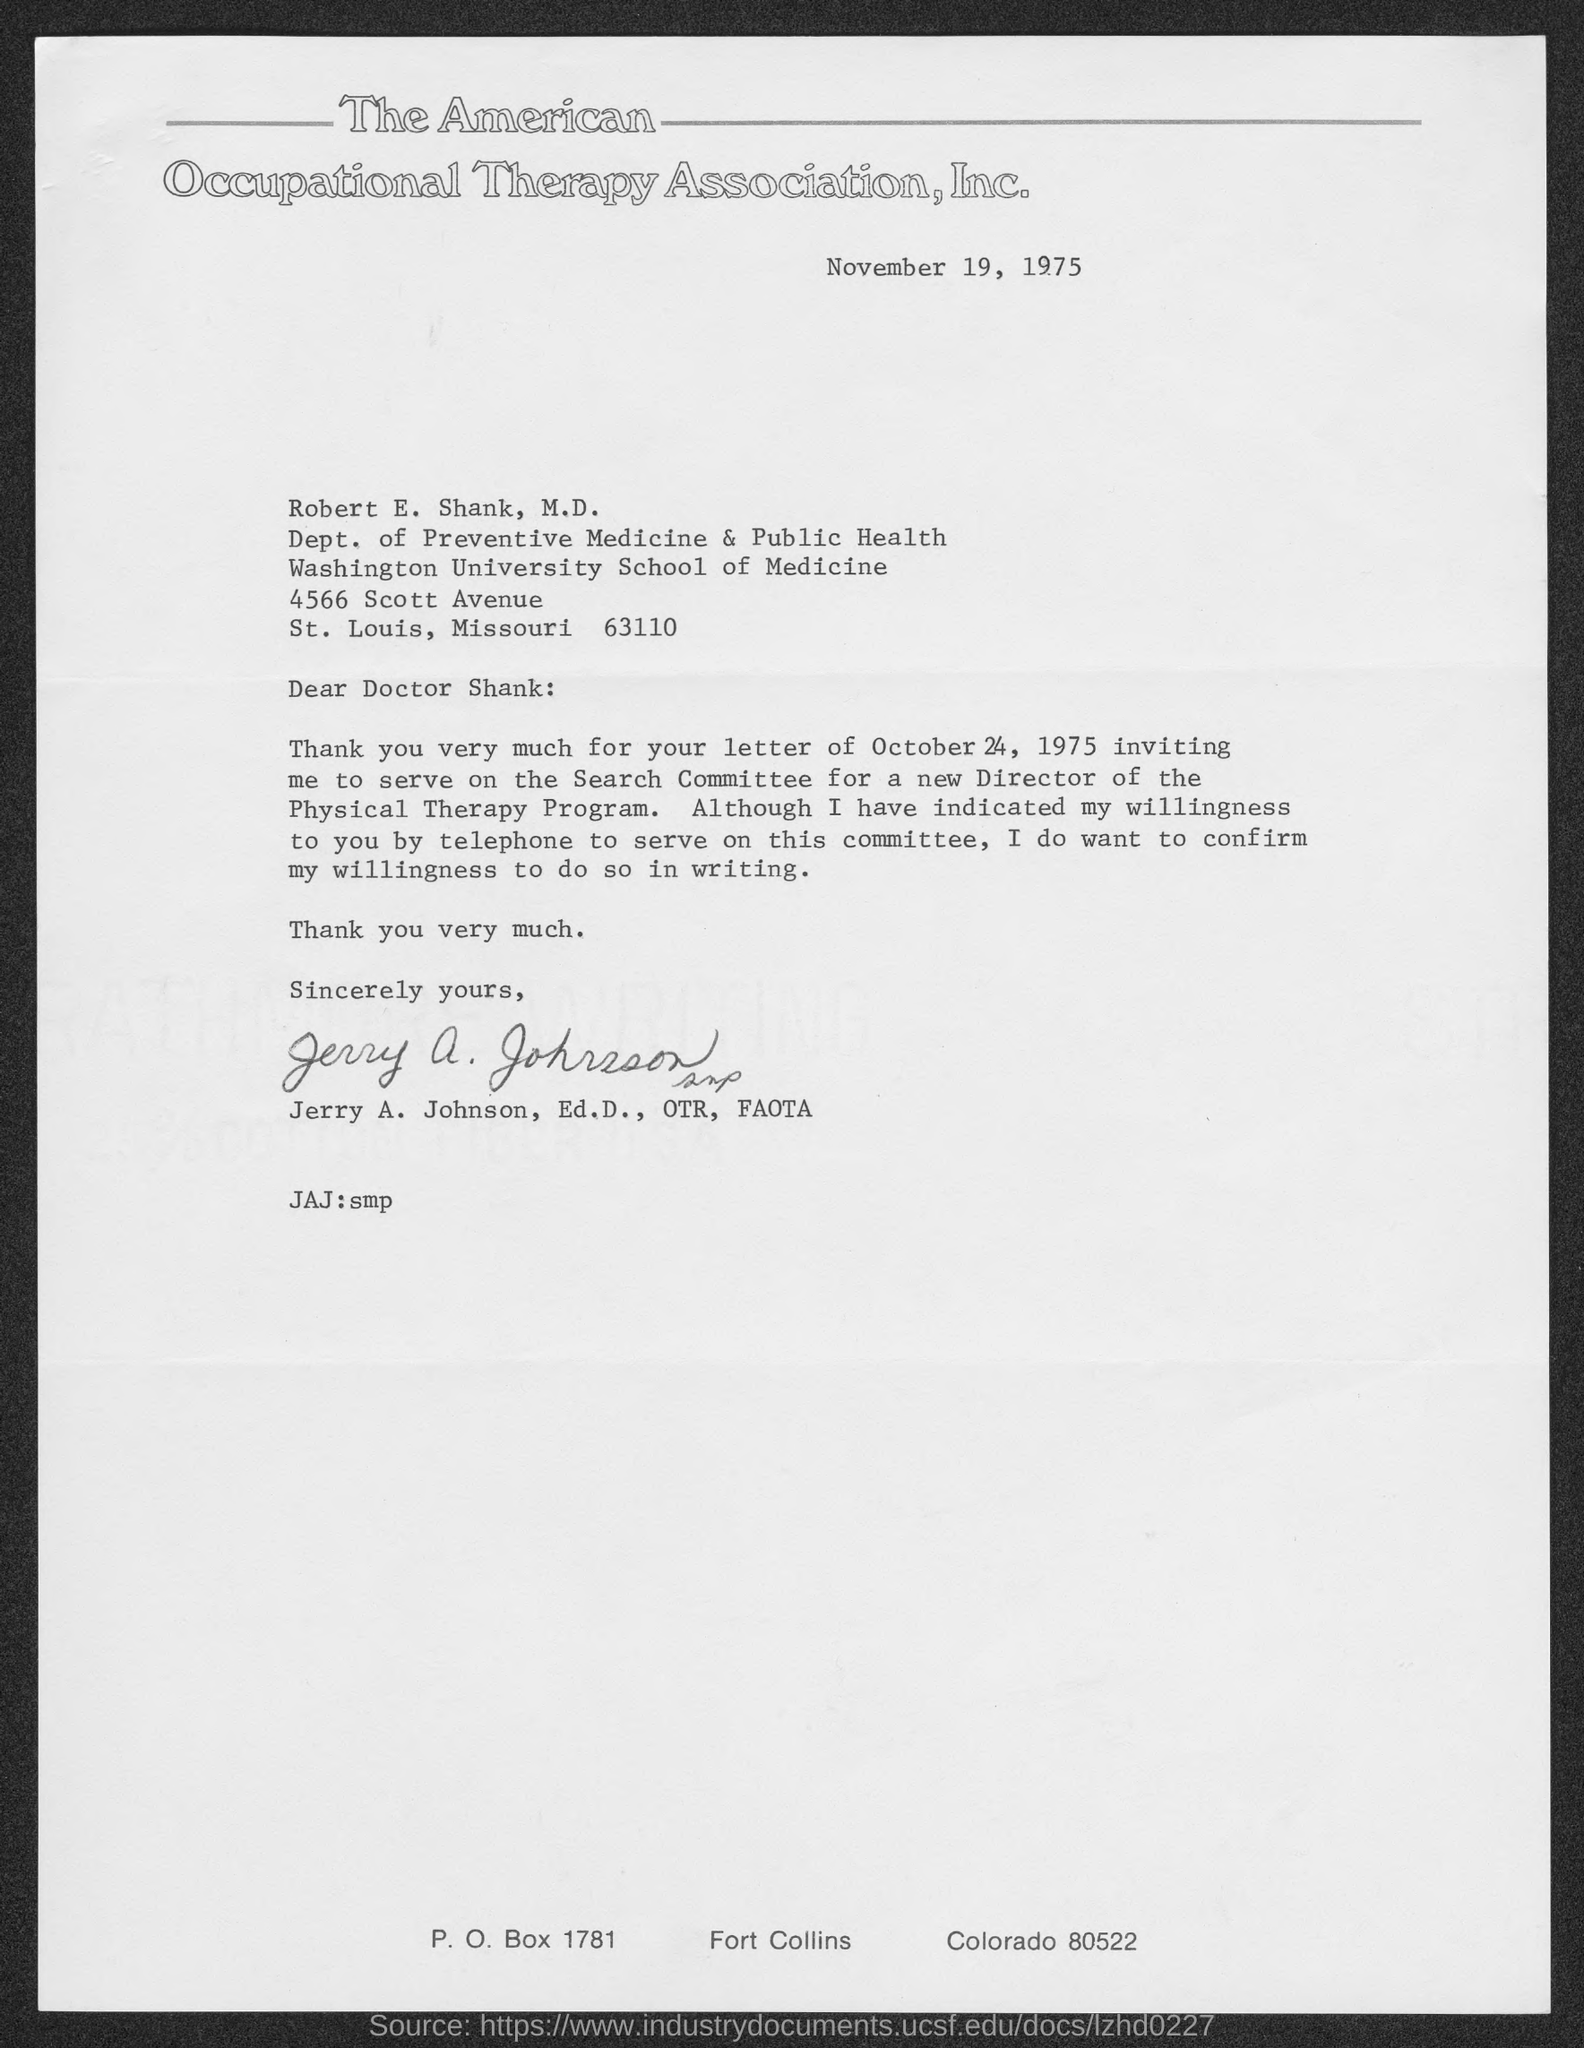What is the postal code of missouri?
Provide a succinct answer. 63110. To whom this letter is written to?
Your answer should be very brief. Robert E. Shank, M.D. Which date the letter is dated on?
Give a very brief answer. November 19, 1975. 